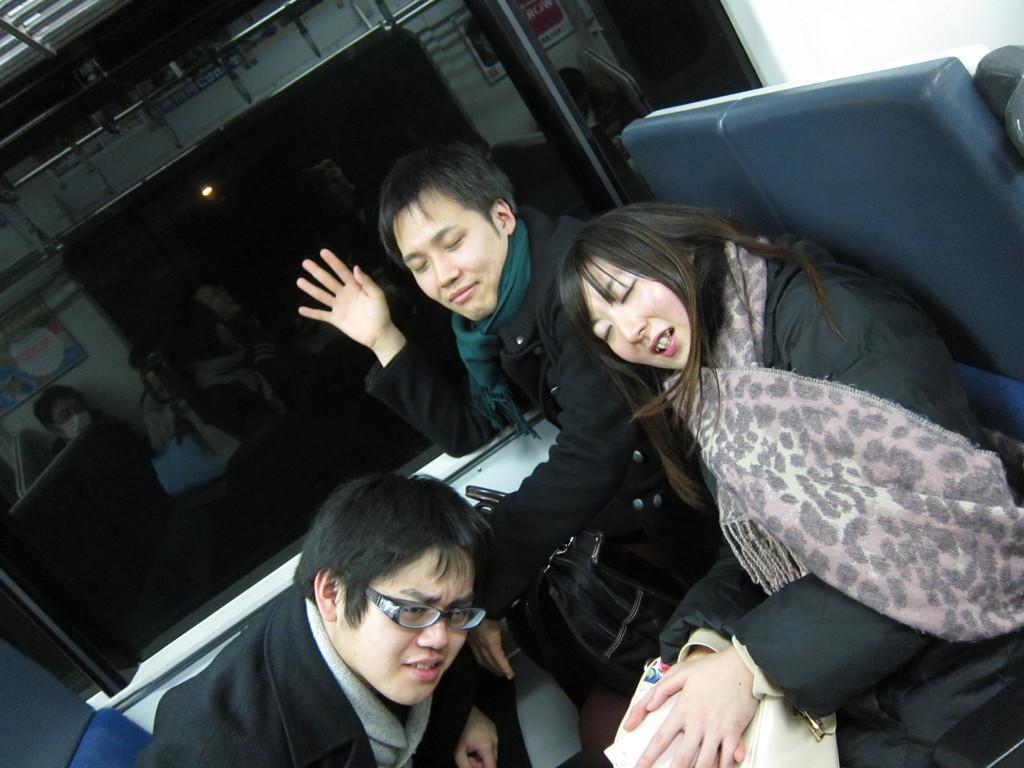Describe this image in one or two sentences. In this image we can see persons sitting on the chairs. In the background we can see window. 